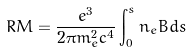Convert formula to latex. <formula><loc_0><loc_0><loc_500><loc_500>R M = \frac { e ^ { 3 } } { 2 \pi m _ { e } ^ { 2 } c ^ { 4 } } \int _ { 0 } ^ { s } n _ { e } B d s</formula> 